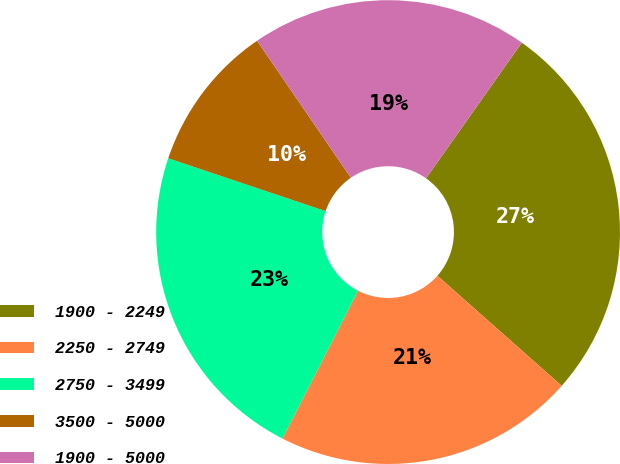<chart> <loc_0><loc_0><loc_500><loc_500><pie_chart><fcel>1900 - 2249<fcel>2250 - 2749<fcel>2750 - 3499<fcel>3500 - 5000<fcel>1900 - 5000<nl><fcel>26.75%<fcel>20.99%<fcel>22.63%<fcel>10.29%<fcel>19.34%<nl></chart> 